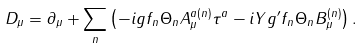Convert formula to latex. <formula><loc_0><loc_0><loc_500><loc_500>D _ { \mu } = \partial _ { \mu } + \sum _ { n } \left ( - i g f _ { n } \Theta _ { n } A _ { \mu } ^ { a ( n ) } \tau ^ { a } - i Y g ^ { \prime } f _ { n } \Theta _ { n } B _ { \mu } ^ { ( n ) } \right ) .</formula> 